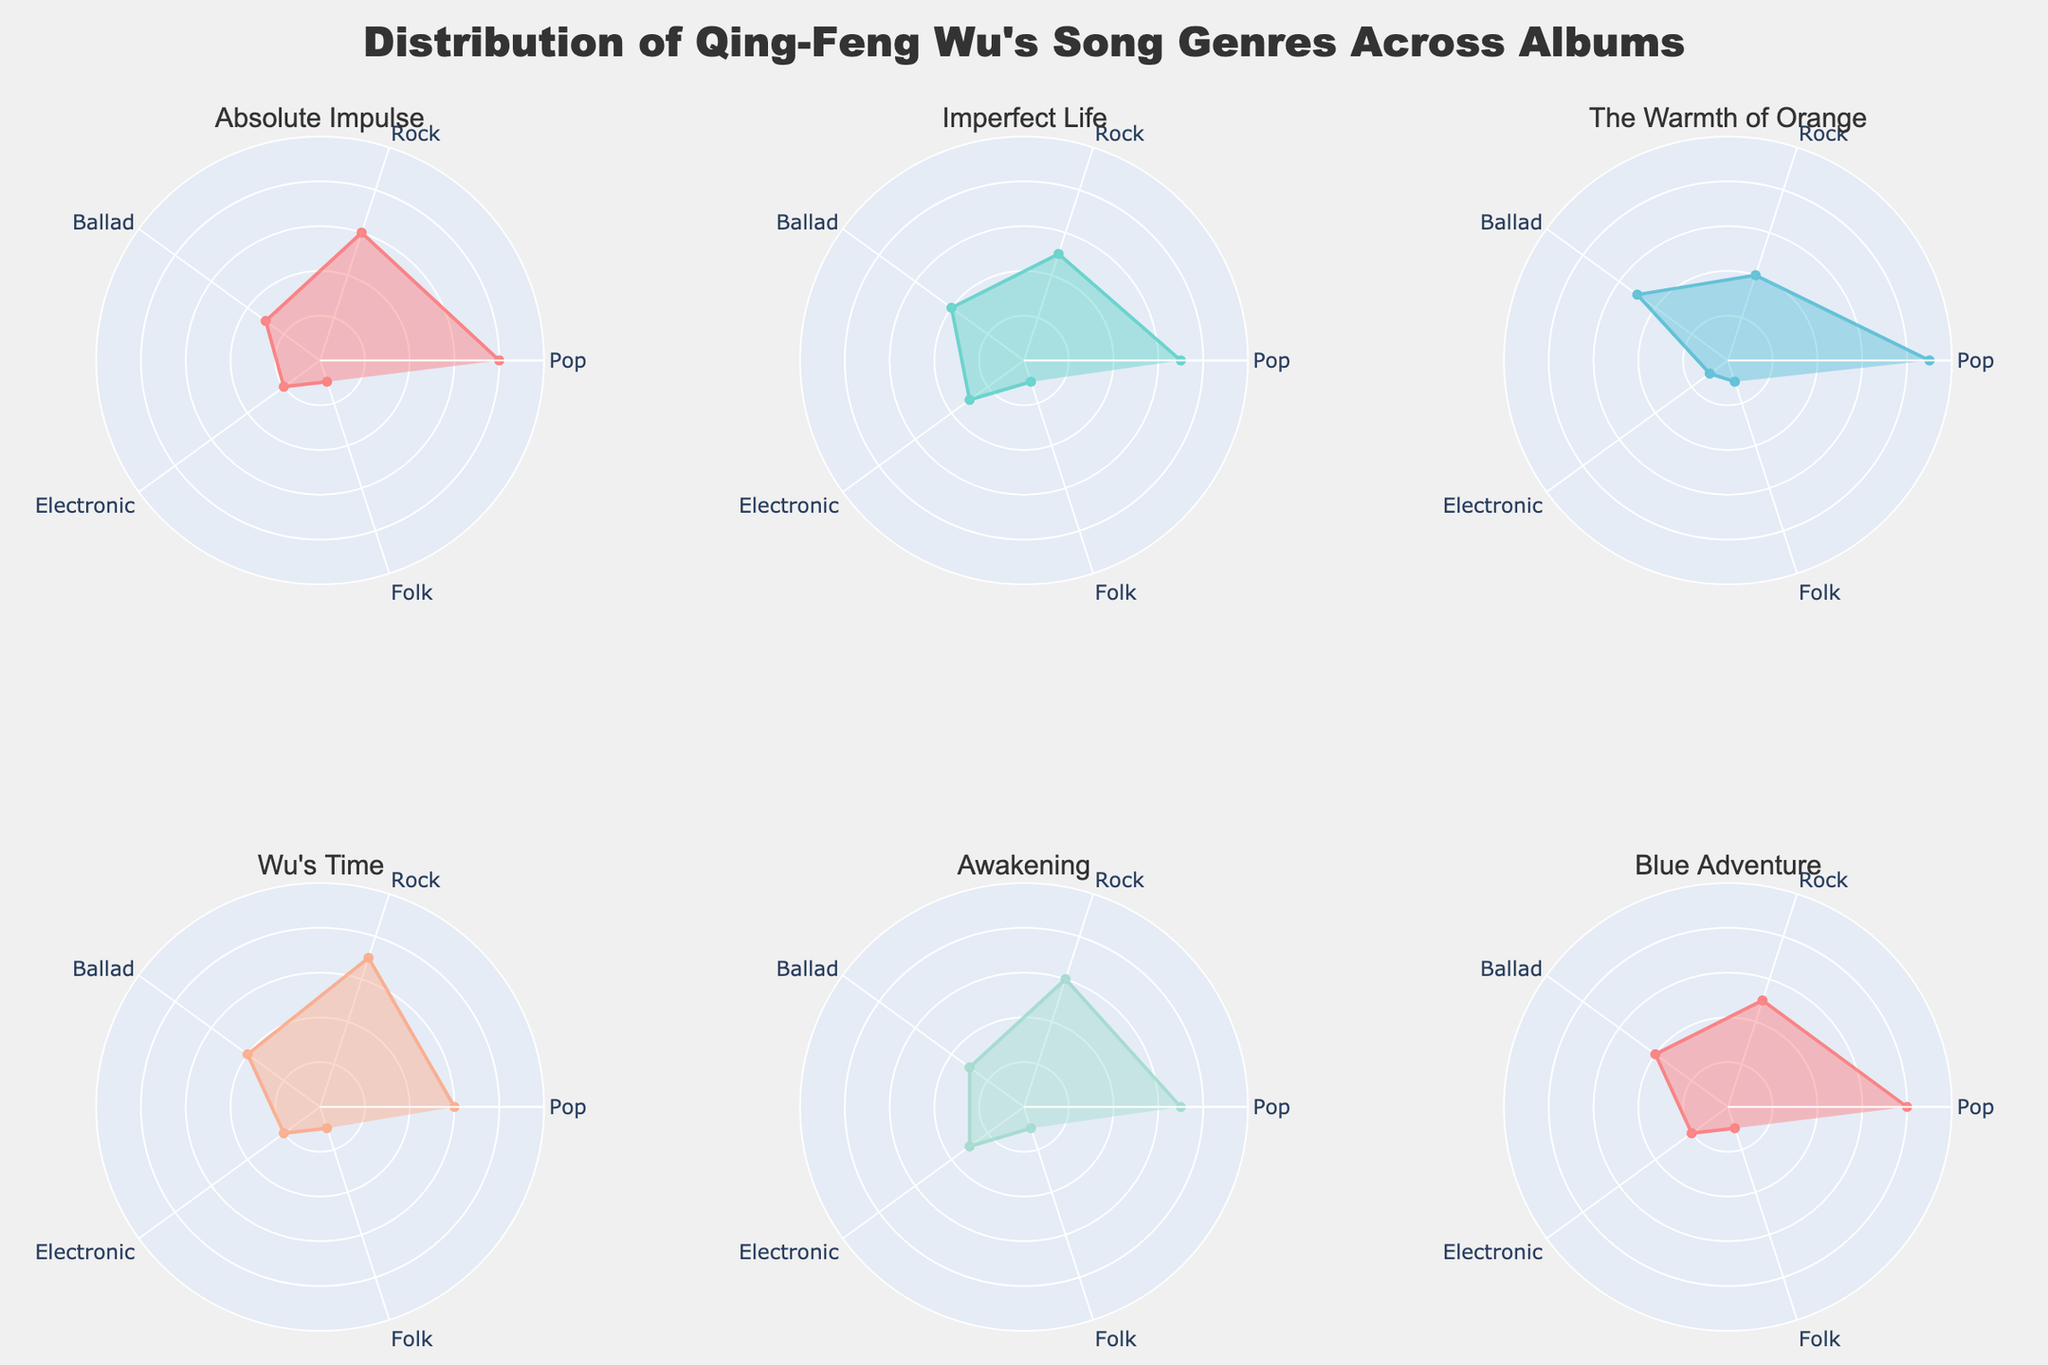Which album has the highest number of Pop songs? Look at the segments on each subplot that represent Pop songs and compare their values. The album with the largest segment for Pop is "The Warmth of Orange" with 45 songs.
Answer: The Warmth of Orange Which genre is consistently the least represented across all albums? Check each subplot for the genre with the smallest segment. The genre that consistently has the fewest songs in each album is Folk.
Answer: Folk Which album has the largest difference between Pop and Rock songs? Calculate the difference between the Pop and Rock values for each album and find the album with the largest difference. "The Warmth of Orange" has 45 Pop and 20 Rock, so the difference is 25, which is the largest among all albums.
Answer: The Warmth of Orange What is the total number of Ballad songs across all albums? Sum up the Ballad values from all albums: 15 + 20 + 25 + 20 + 15 + 20 = 115.
Answer: 115 Do any albums have an equal number of Electronic and Rock songs? Look at each subplot and compare the values for Electronic and Rock genres. None of the albums have these two genres equal in value.
Answer: No Which album has the smallest proportion of Electronic songs relative to its total songs? Calculate the proportion of Electronic songs for each album: 
For "Absolute Impulse": (10/100)*100 = 10
For "Imperfect Life": (15/100)*100 = 15
For "The Warmth of Orange": (5/100)*100 = 5
For "Wu's Time": (10/100)*100 = 10
For "Awakening": (15/100)*100 = 15
For "Blue Adventure": (10/100)*100 = 10
"The Warmth of Orange" has the smallest proportion.
Answer: The Warmth of Orange Which genre has the highest combined total across all albums? Sum up the values for each genre across all albums and compare:
Pop: 40 + 35 + 45 + 30 + 35 + 40 = 225
Rock: 30 + 25 + 20 + 35 + 30 + 25 = 165
Ballad: 15 + 20 + 25 + 20 + 15 + 20 = 115
Electronic: 10 + 15 + 5 + 10 + 15 + 10 = 65
Folk: 5 + 5 + 5 + 5 + 5 + 5 = 30
Pop has the highest combined total.
Answer: Pop 